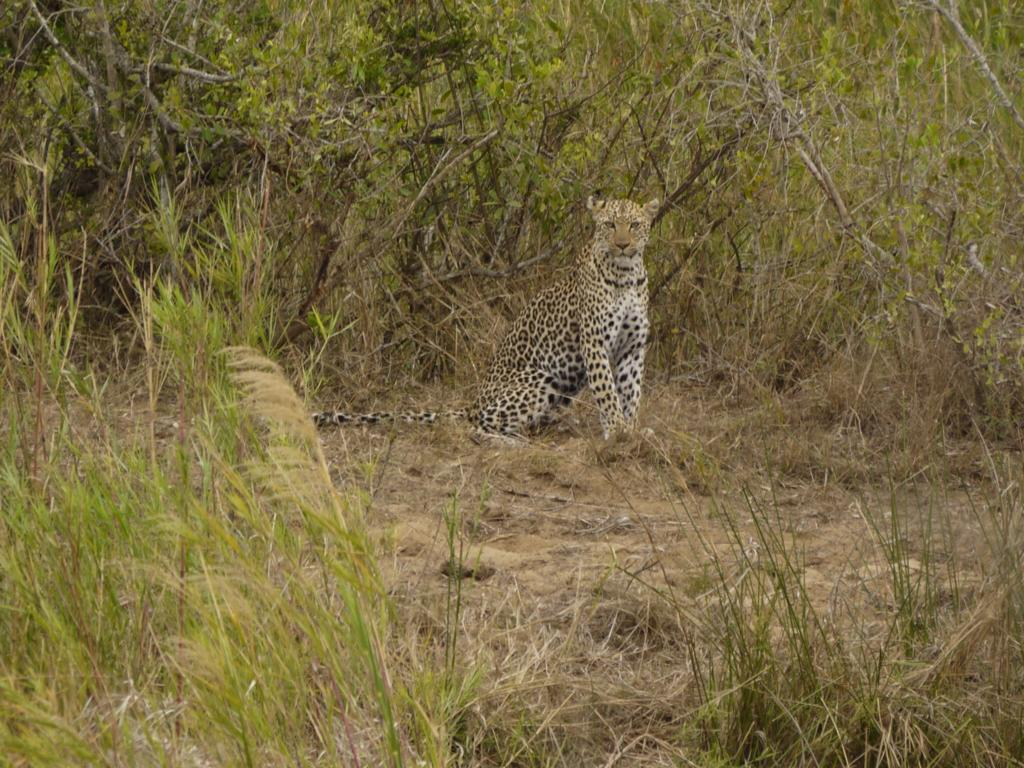What type of vegetation is in the foreground of the image? There is green grass in the foreground of the image. What can be seen in the image besides the green grass? There is an animal visible in the image. What type of natural scenery is in the background of the image? There are trees in the background of the image. What type of harmony is being celebrated at the party in the image? There is no party present in the image, so it is not possible to determine what type of harmony might be celebrated. 